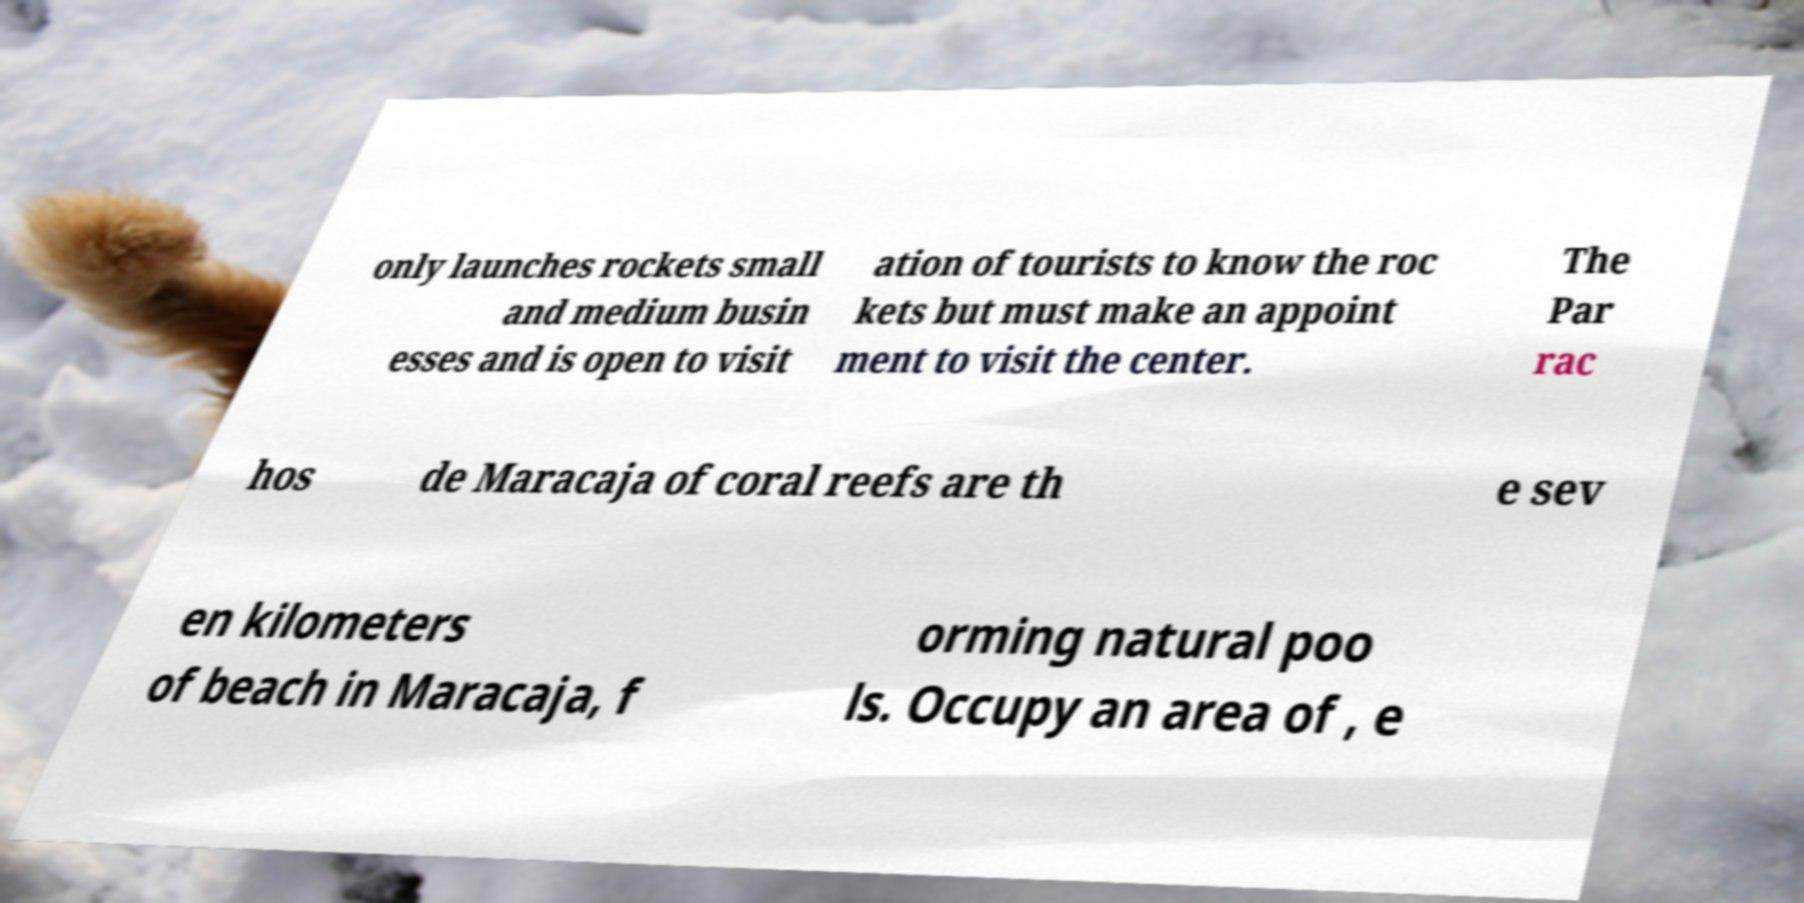Please identify and transcribe the text found in this image. only launches rockets small and medium busin esses and is open to visit ation of tourists to know the roc kets but must make an appoint ment to visit the center. The Par rac hos de Maracaja of coral reefs are th e sev en kilometers of beach in Maracaja, f orming natural poo ls. Occupy an area of , e 